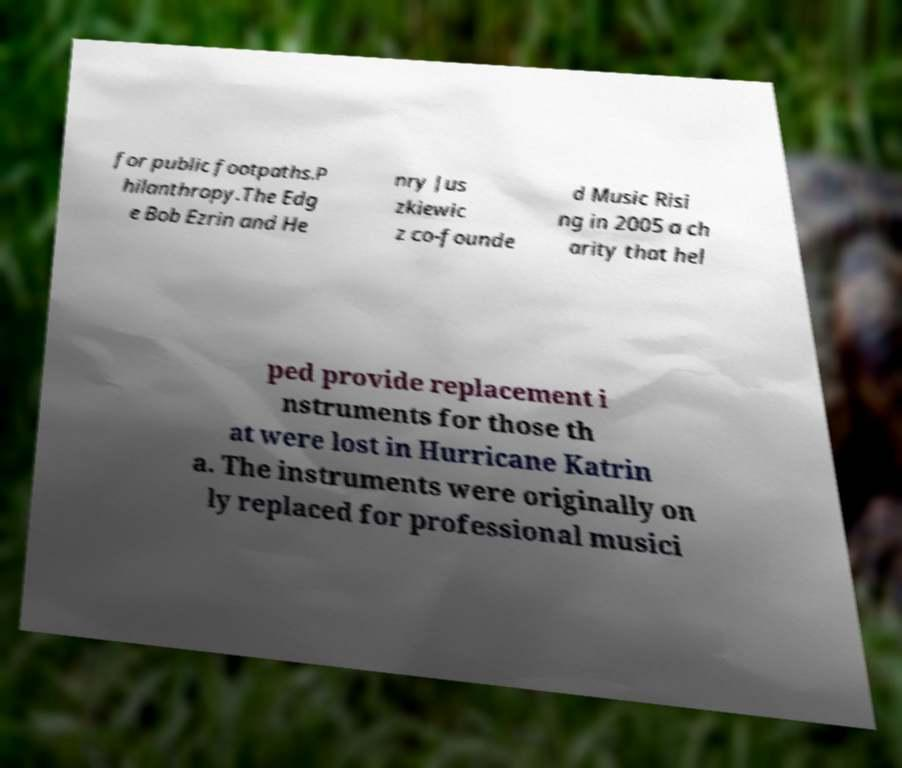Could you assist in decoding the text presented in this image and type it out clearly? for public footpaths.P hilanthropy.The Edg e Bob Ezrin and He nry Jus zkiewic z co-founde d Music Risi ng in 2005 a ch arity that hel ped provide replacement i nstruments for those th at were lost in Hurricane Katrin a. The instruments were originally on ly replaced for professional musici 